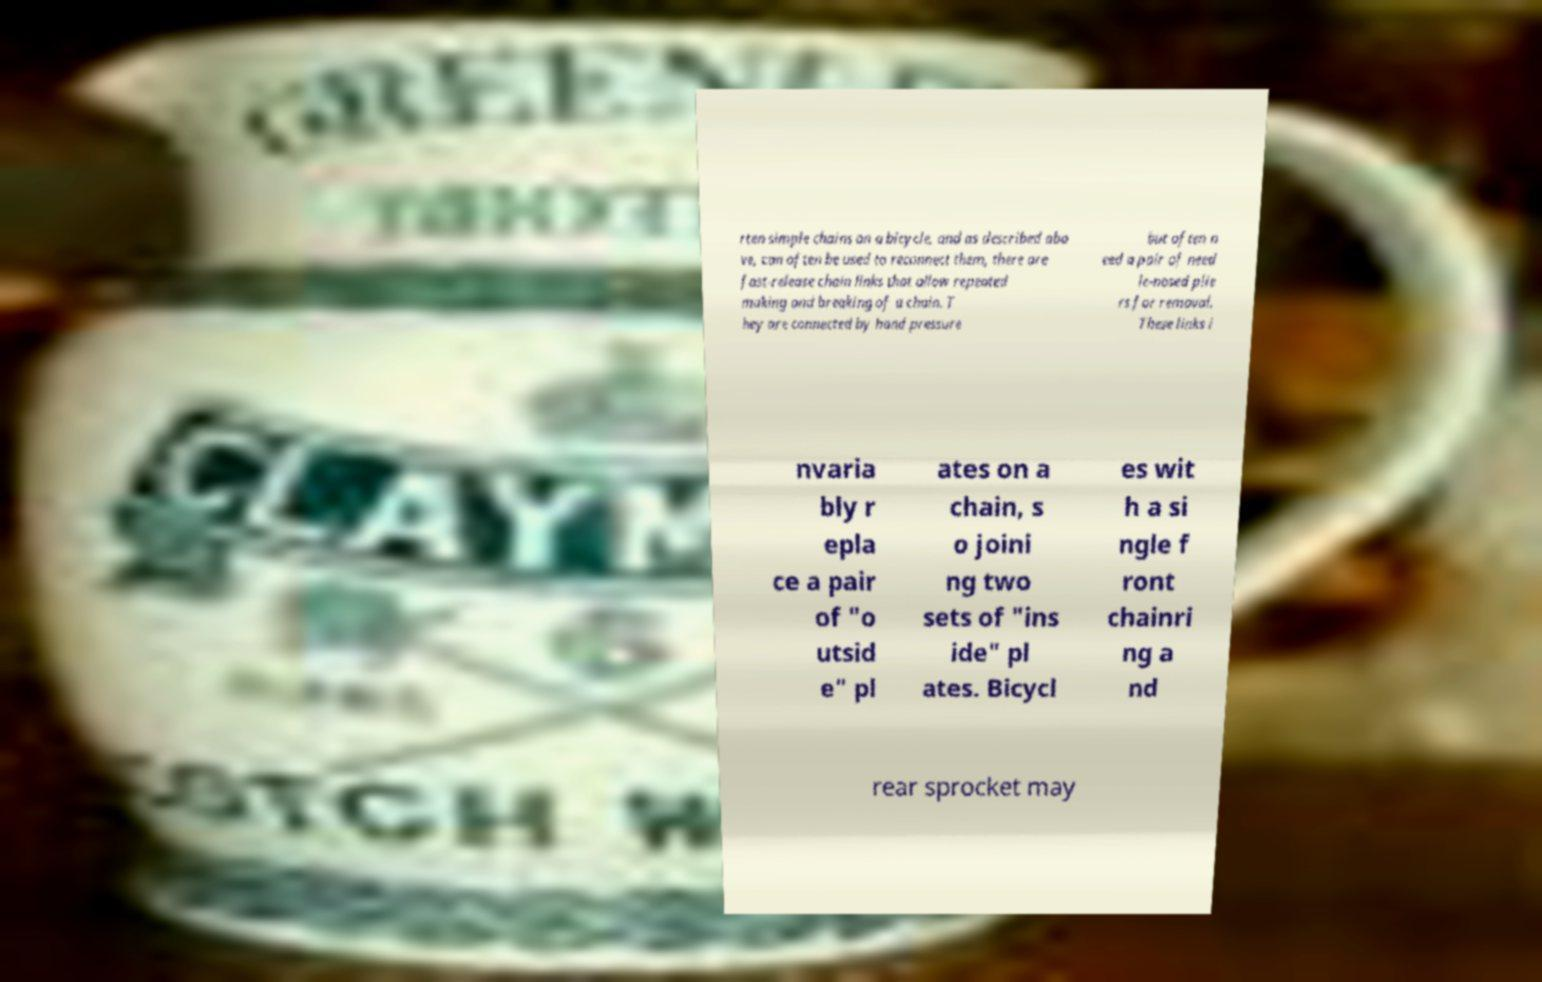What messages or text are displayed in this image? I need them in a readable, typed format. rten simple chains on a bicycle, and as described abo ve, can often be used to reconnect them, there are fast-release chain links that allow repeated making and breaking of a chain. T hey are connected by hand pressure but often n eed a pair of need le-nosed plie rs for removal. These links i nvaria bly r epla ce a pair of "o utsid e" pl ates on a chain, s o joini ng two sets of "ins ide" pl ates. Bicycl es wit h a si ngle f ront chainri ng a nd rear sprocket may 